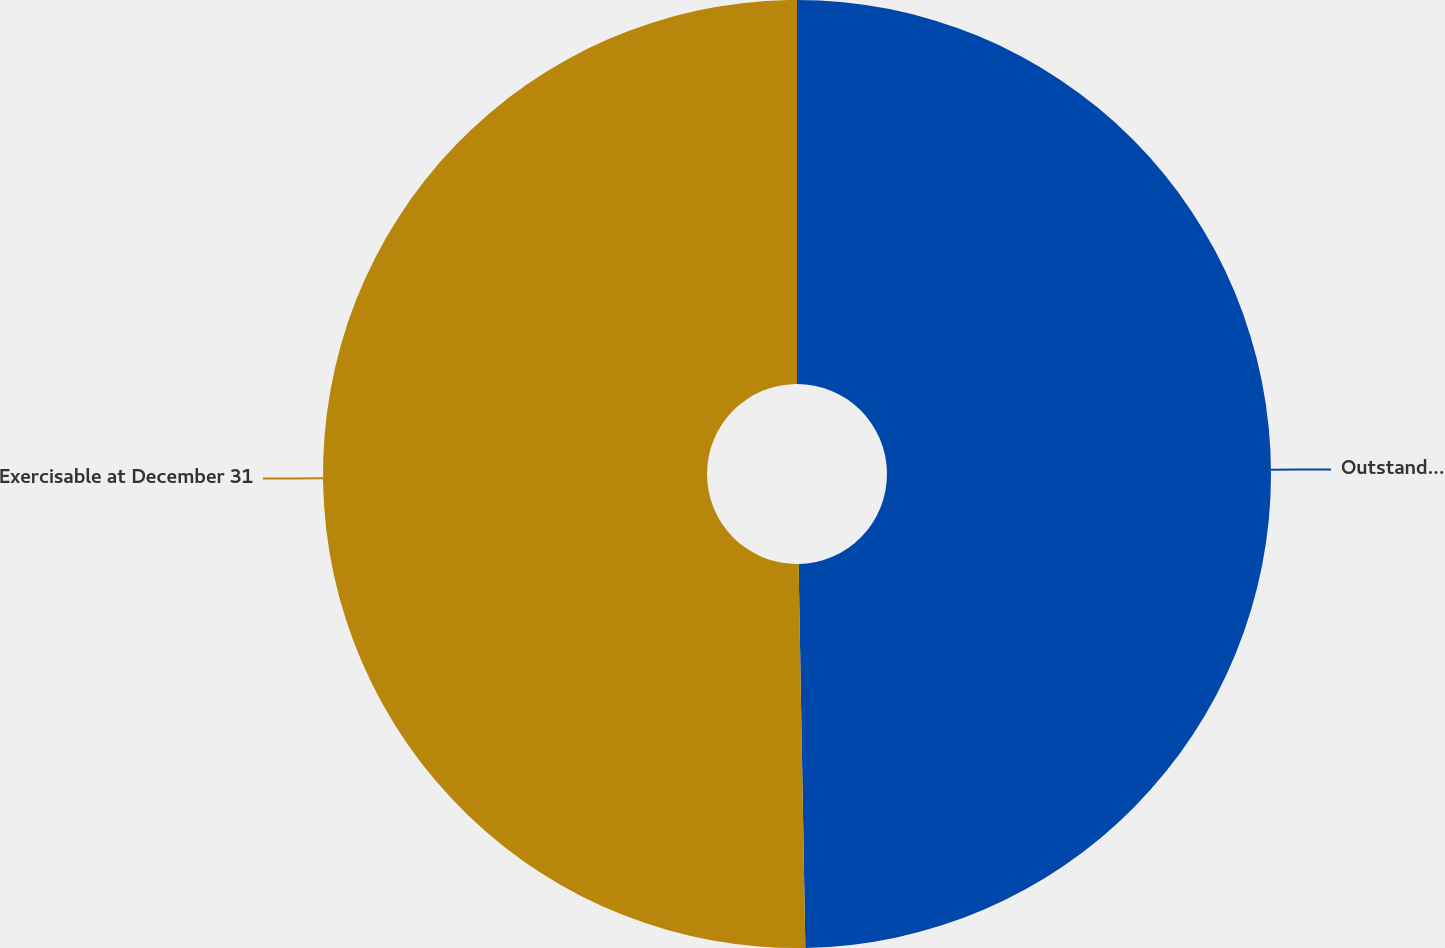<chart> <loc_0><loc_0><loc_500><loc_500><pie_chart><fcel>Outstanding at December 31<fcel>Exercisable at December 31<nl><fcel>49.72%<fcel>50.28%<nl></chart> 